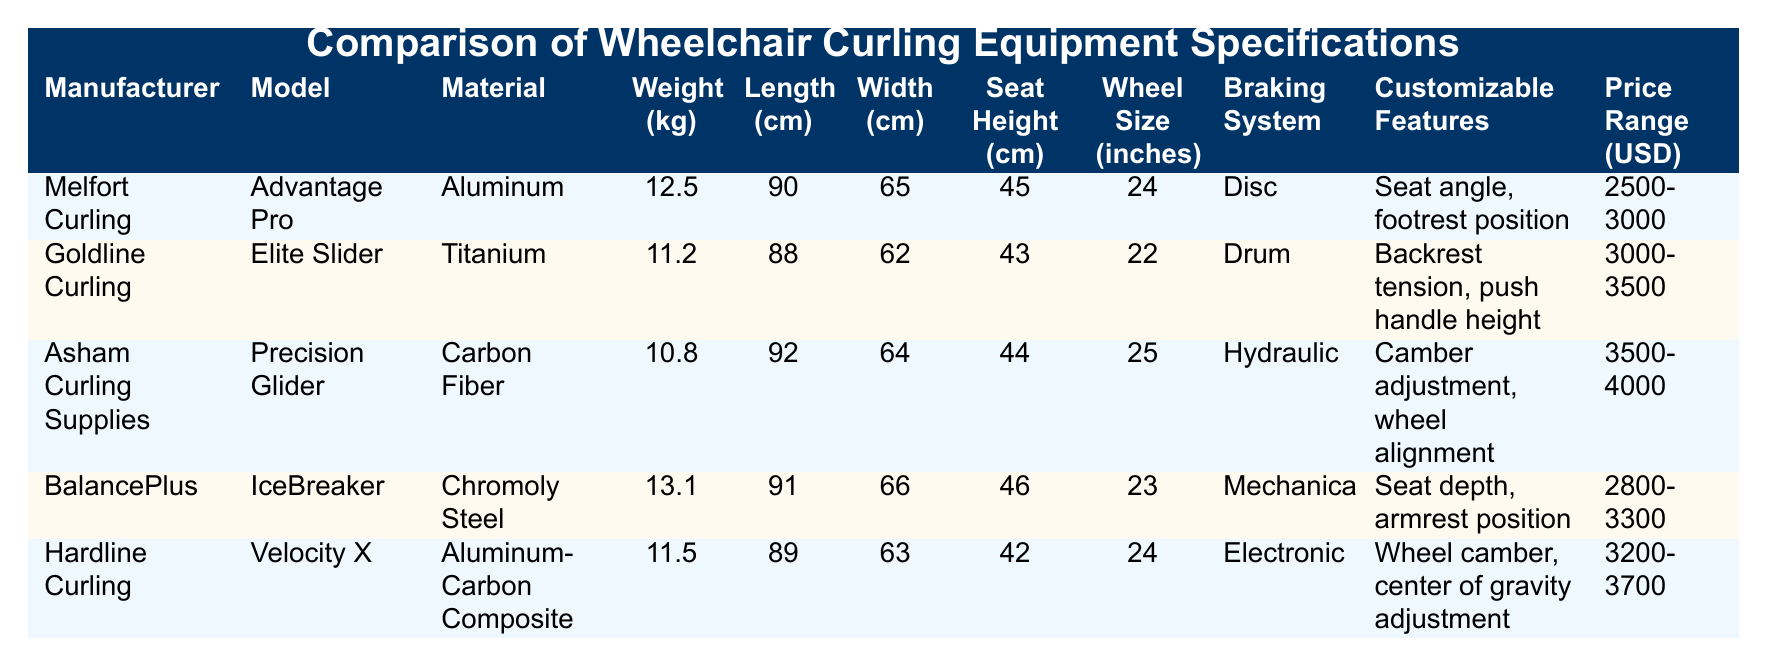What is the weight of the Asham Curling Supplies Precision Glider? The table lists the weight under the "Weight (kg)" column for each model. For the Asham Curling Supplies Precision Glider, the corresponding weight is 10.8 kg.
Answer: 10.8 kg Which model has the highest seat height? By comparing the "Seat Height (cm)" column for all models, the BalancePlus IceBreaker has the highest seat height at 46 cm.
Answer: 46 cm Is the Goldline Curling Elite Slider made of titanium? The table shows that the material for the Goldline Curling Elite Slider is indeed listed as Titanium, confirming that this fact is true.
Answer: Yes What is the price range for the Hardline Curling Velocity X? The price range is indicated in the "Price Range (USD)" column. For the Hardline Curling Velocity X, the price range is 3200-3700 USD.
Answer: 3200-3700 USD Which model is the heaviest and how much does it weigh? Checking the "Weight (kg)" column, the heaviest model is the BalancePlus IceBreaker at 13.1 kg.
Answer: 13.1 kg What is the average weight of all models? To find the average, sum the weights of all models: 12.5 + 11.2 + 10.8 + 13.1 + 11.5 = 59.1 kg. There are 5 models, so the average weight is 59.1 kg / 5 = 11.82 kg.
Answer: 11.82 kg Is there a model with a hydraulic braking system? By reviewing the "Braking System" column, we can see that the Asham Curling Supplies Precision Glider has a hydraulic braking system.
Answer: Yes Which model has the lowest price range? By assessing the "Price Range (USD)" column, the Melfort Curling Advantage Pro has the lowest price range, listed as 2500-3000 USD.
Answer: 2500-3000 USD 